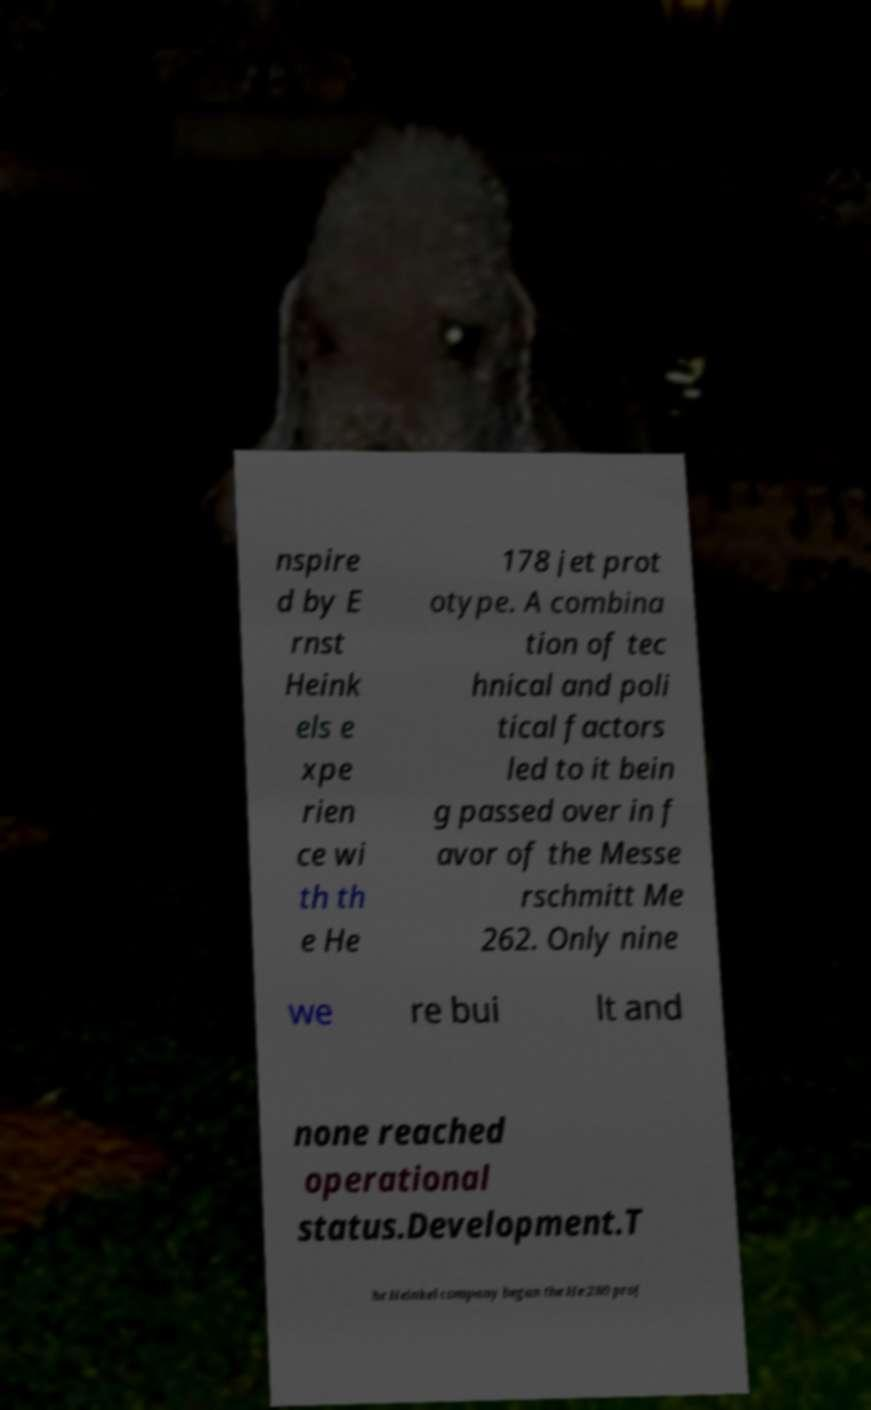Please identify and transcribe the text found in this image. nspire d by E rnst Heink els e xpe rien ce wi th th e He 178 jet prot otype. A combina tion of tec hnical and poli tical factors led to it bein g passed over in f avor of the Messe rschmitt Me 262. Only nine we re bui lt and none reached operational status.Development.T he Heinkel company began the He 280 proj 